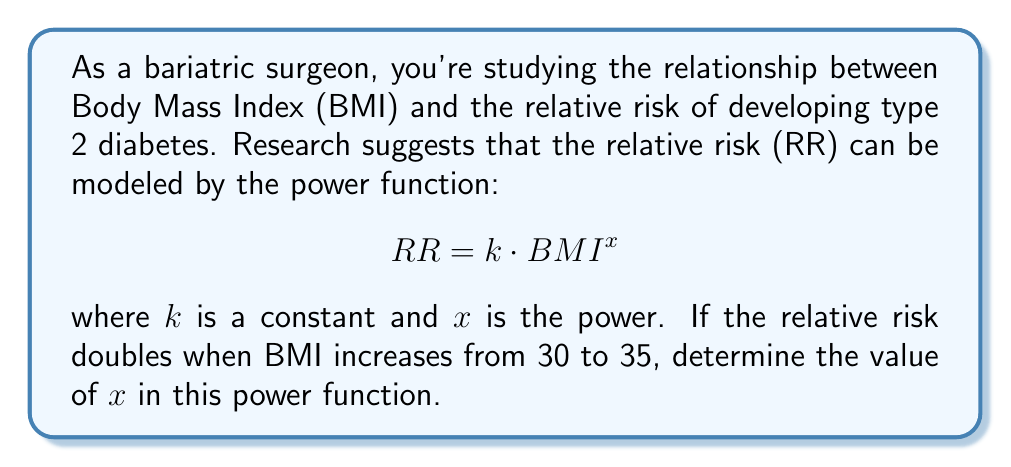Solve this math problem. Let's approach this step-by-step:

1) We're given that the relative risk doubles when BMI increases from 30 to 35. Let's express this mathematically:

   $$ \frac{RR_{35}}{RR_{30}} = 2 $$

2) Now, let's substitute the power function for each RR:

   $$ \frac{k \cdot 35^x}{k \cdot 30^x} = 2 $$

3) The constant $k$ cancels out:

   $$ \frac{35^x}{30^x} = 2 $$

4) We can rewrite this as:

   $$ \left(\frac{35}{30}\right)^x = 2 $$

5) Taking the natural logarithm of both sides:

   $$ x \cdot \ln\left(\frac{35}{30}\right) = \ln(2) $$

6) Solve for $x$:

   $$ x = \frac{\ln(2)}{\ln\left(\frac{35}{30}\right)} $$

7) Calculate the value:

   $$ x \approx \frac{0.6931}{0.1542} \approx 4.4946 $$

Therefore, the power $x$ in the relative risk function is approximately 4.4946.
Answer: $x \approx 4.4946$ 